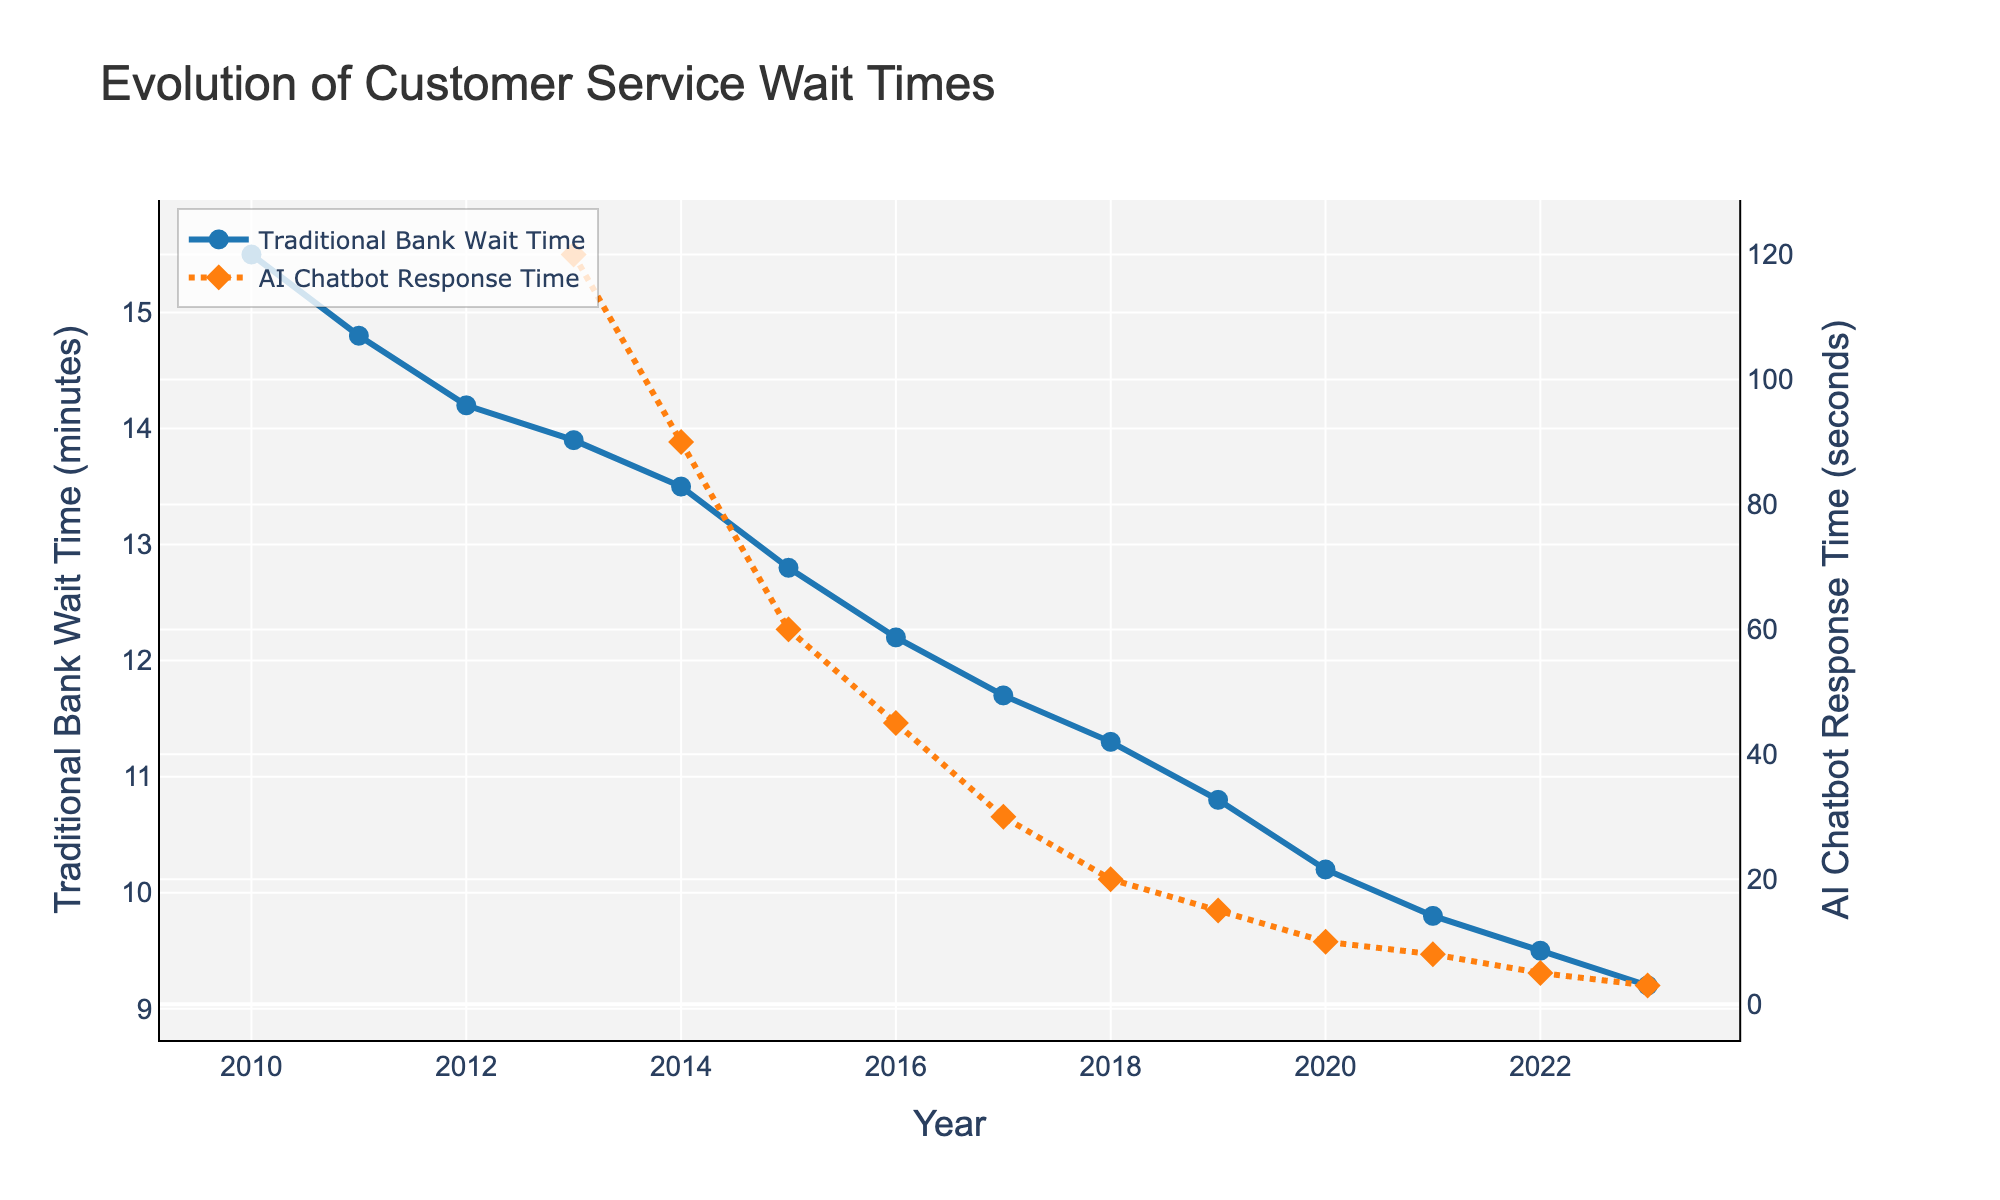What is the overall trend in traditional bank wait times from 2010 to 2023? The line representing traditional bank wait times shows a general downward trend from 2010 to 2023, decreasing from 15.5 minutes to 9.2 minutes. This indicates that traditional banks have managed to reduce wait times over the years.
Answer: Downward trend When did AI chatbots first start being used for customer service, and what was their initial response time? AI chatbots first appeared in the data in 2013 with an initial response time of 120 seconds. This can be observed from the line representing AI chatbot response times, which starts at 2013.
Answer: 2013, 120 seconds By how much has the traditional bank wait time decreased from 2010 to 2023? The wait time decreased from 15.5 minutes in 2010 to 9.2 minutes in 2023. To find the decrease, subtract the 2023 value from the 2010 value: 15.5 - 9.2 = 6.3 minutes.
Answer: 6.3 minutes Which year observes the largest difference in wait time between traditional banks and AI chatbots, and what is that difference? To find the largest difference, compare the values for each year from 2013 onwards. The largest difference is in 2013: traditional banks had a wait time of 13.9 minutes, while AI chatbots had 120 seconds (2 minutes), so the difference is 13.9 - 2 = 11.9 minutes.
Answer: 2013, 11.9 minutes How do the wait times for traditional banks in 2023 compare to AI chatbot response times in 2013? In 2023, the wait time for traditional banks is 9.2 minutes. In 2013, the AI chatbot response time is 120 seconds (2 minutes). Since 9.2 minutes is significantly longer than 2 minutes, traditional banks in 2023 still have longer wait times compared to AI chatbots in 2013.
Answer: Longer in 2023 for banks What is the average AI chatbot response time from 2013 to 2023? To find the average, sum the AI chatbot response times for each year from 2013 to 2023 and divide by the number of years: (120 + 90 + 60 + 45 + 30 + 20 + 15 + 10 + 8 + 5 + 3) / 11 = 406 / 11 ≈ 36.9 seconds.
Answer: 36.9 seconds Between which consecutive years did the traditional bank wait time decrease the most? Calculate the year-to-year differences for traditional bank wait times and identify the largest decrease: 2010-2011: 0.7, 2011-2012: 0.6, 2012-2013: 0.3, 2013-2014: 0.4, 2014-2015: 0.7, 2015-2016: 0.6, 2016-2017: 0.5, 2017-2018: 0.4, 2018-2019: 0.5, 2019-2020: 0.6, 2020-2021: 0.4, 2021-2022: 0.3, 2022-2023: 0.3. The largest decrease is 0.7 in two periods: 2010-2011 and 2014-2015.
Answer: 2010-2011 and 2014-2015 Is there a year when both traditional bank wait time and AI chatbot response time decreased, and how can you identify it? To identify such a year, look for years where both lines show a downward trend. From the data, both wait times decrease each year from 2014 onwards.
Answer: Each year from 2014 onwards What visual differences help you distinguish between the two lines representing traditional bank wait times and AI chatbot response times? The traditional bank wait time line is solid with circle markers and colored in blue, while the AI chatbot response time line is dotted with diamond markers and colored in orange.
Answer: Line style and color In which year did AI chatbots achieve response times less than 10 seconds, and how do you find it? The AI chatbot response time drops below 10 seconds in 2020, as observed from the line where 2020’s marker corresponds to a value of 10 seconds.
Answer: 2020 